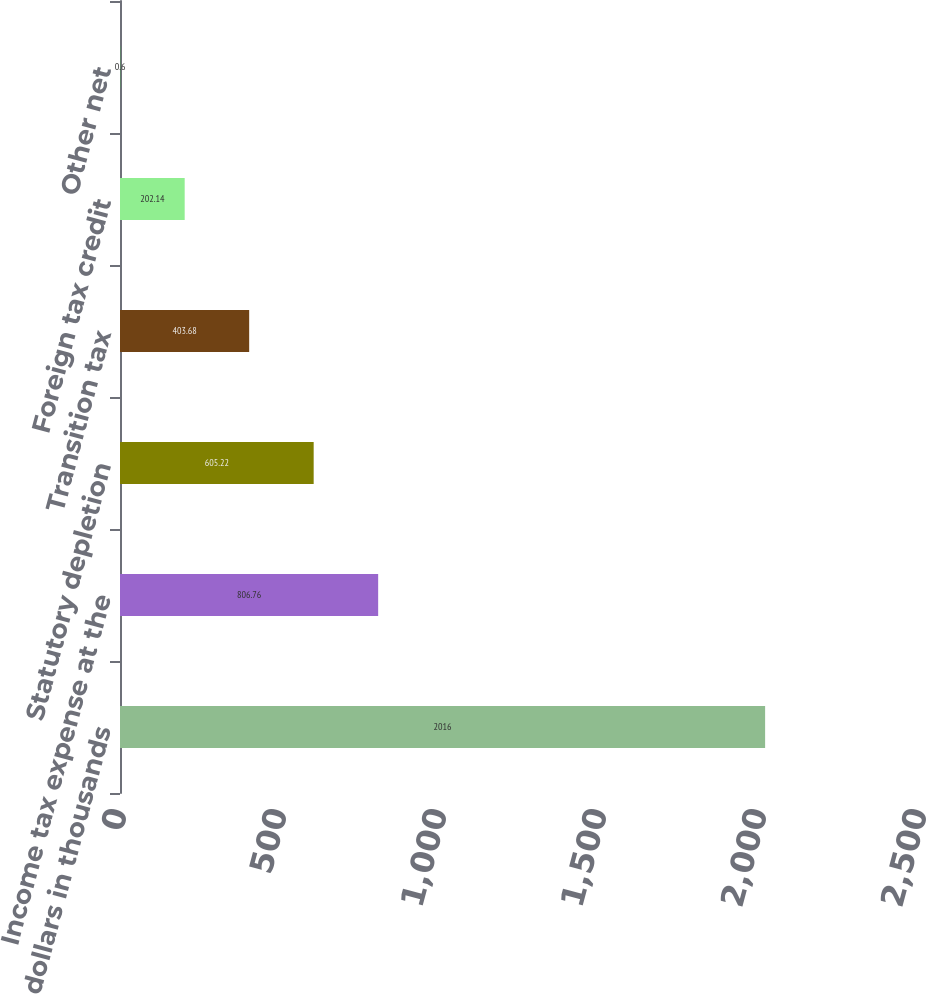<chart> <loc_0><loc_0><loc_500><loc_500><bar_chart><fcel>dollars in thousands<fcel>Income tax expense at the<fcel>Statutory depletion<fcel>Transition tax<fcel>Foreign tax credit<fcel>Other net<nl><fcel>2016<fcel>806.76<fcel>605.22<fcel>403.68<fcel>202.14<fcel>0.6<nl></chart> 